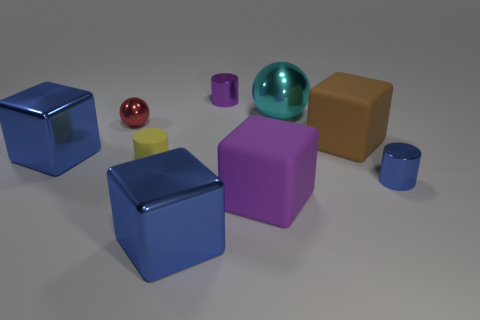How many objects are either yellow rubber cylinders that are left of the big brown block or big brown blocks?
Ensure brevity in your answer.  2. There is a purple object that is the same material as the yellow thing; what is its size?
Make the answer very short. Large. How many metal cubes are the same color as the tiny shiny ball?
Your answer should be compact. 0. What number of tiny objects are either purple objects or red rubber cylinders?
Provide a short and direct response. 1. Is there a tiny yellow cylinder that has the same material as the blue cylinder?
Offer a terse response. No. What is the material of the cylinder behind the small red ball?
Provide a short and direct response. Metal. There is a large matte cube that is in front of the tiny blue shiny cylinder; is it the same color as the metal cylinder that is in front of the small purple metallic cylinder?
Make the answer very short. No. What color is the other matte object that is the same size as the red object?
Ensure brevity in your answer.  Yellow. How many other objects are there of the same shape as the large purple rubber object?
Your answer should be very brief. 3. What is the size of the sphere that is in front of the large cyan metal thing?
Offer a terse response. Small. 